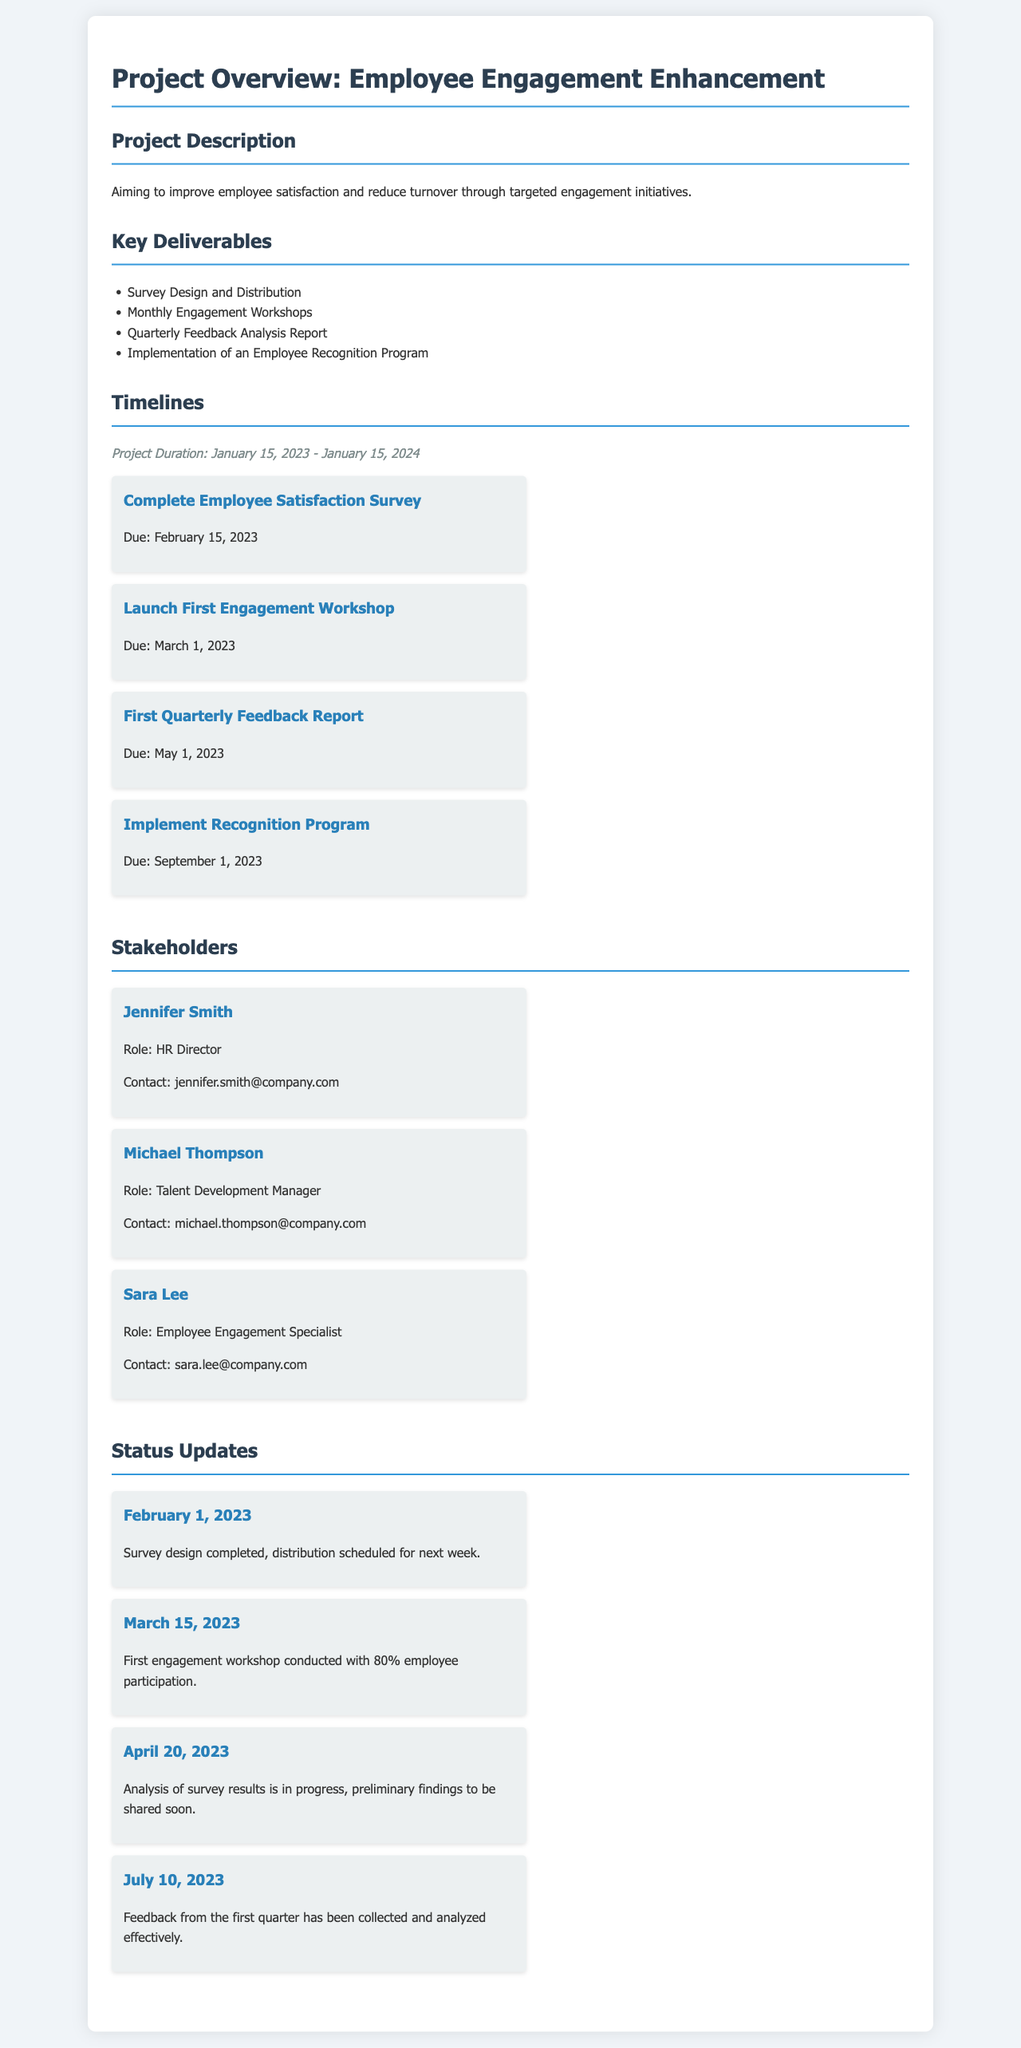what is the project duration? The project duration is indicated at the beginning of the timelines section, which spans from January 15, 2023, to January 15, 2024.
Answer: January 15, 2023 - January 15, 2024 who is the HR Director? The document lists the stakeholders, and Jennifer Smith is identified as the HR Director.
Answer: Jennifer Smith when is the due date for the recognition program? The timeline specifies that the implementation of the recognition program is due on September 1, 2023.
Answer: September 1, 2023 how many engagement workshops are planned? The key deliverables section outlines that there will be monthly engagement workshops, which indicates twelve workshops over the year.
Answer: Twelve what percentage of employee participation was achieved in the first engagement workshop? The status update for March 15, 2023, reports 80% employee participation in the first engagement workshop.
Answer: 80% what is the role of Sara Lee? The stakeholders section mentions Sara Lee in relation to her role within the project.
Answer: Employee Engagement Specialist what is the latest status update date mentioned? The status updates are dated, with the latest one being July 10, 2023.
Answer: July 10, 2023 what is one method used to analyze employee engagement feedback? The key deliverables include producing a quarterly feedback analysis report, which is a method for analyzing feedback.
Answer: Quarterly Feedback Analysis Report 